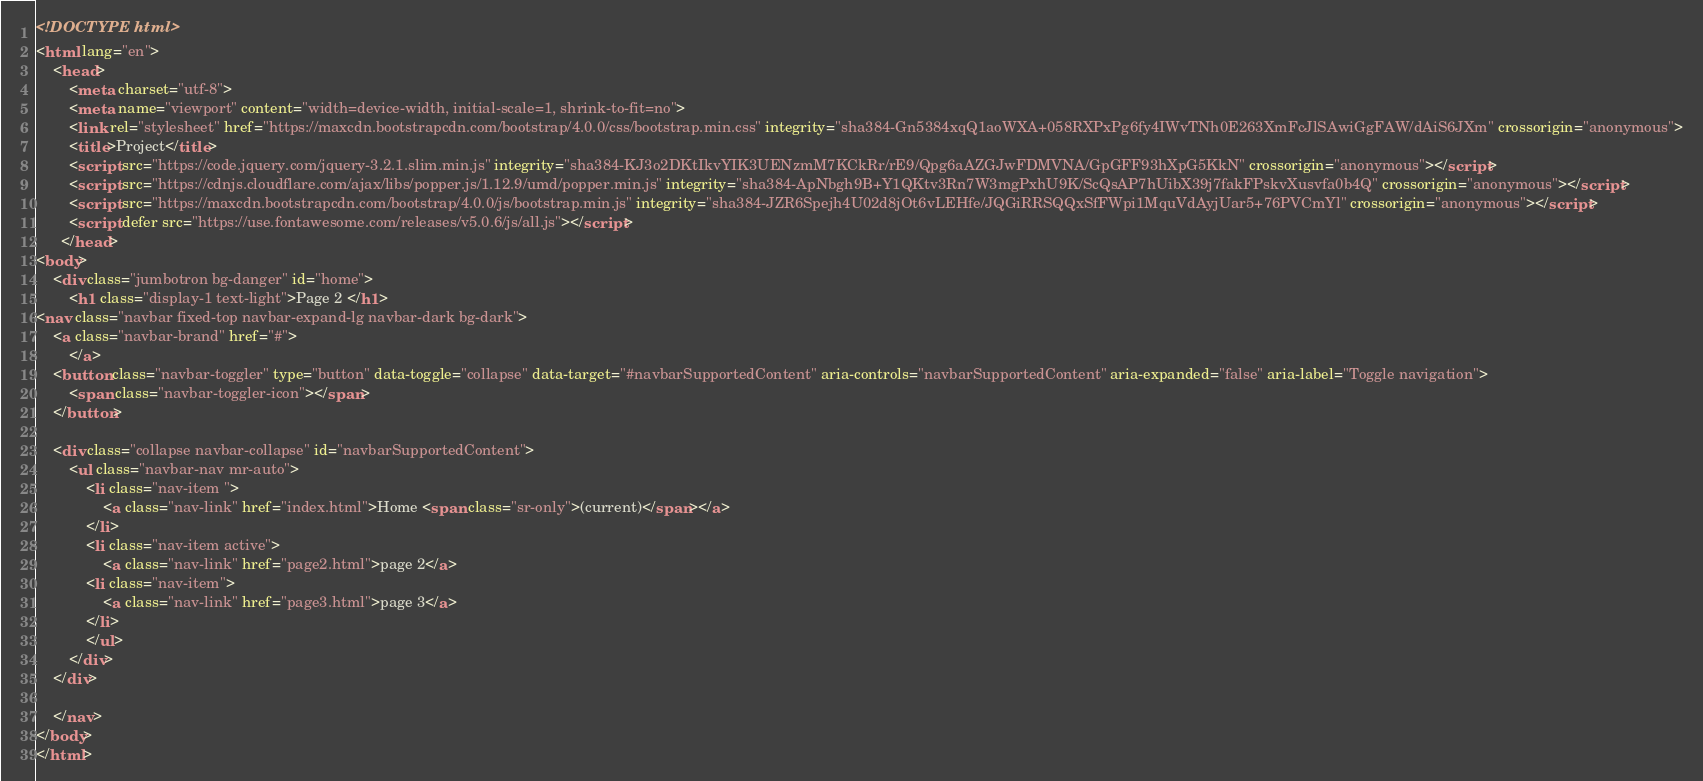Convert code to text. <code><loc_0><loc_0><loc_500><loc_500><_HTML_><!DOCTYPE html>
<html lang="en">
    <head>
        <meta charset="utf-8">
        <meta name="viewport" content="width=device-width, initial-scale=1, shrink-to-fit=no">
        <link rel="stylesheet" href="https://maxcdn.bootstrapcdn.com/bootstrap/4.0.0/css/bootstrap.min.css" integrity="sha384-Gn5384xqQ1aoWXA+058RXPxPg6fy4IWvTNh0E263XmFcJlSAwiGgFAW/dAiS6JXm" crossorigin="anonymous">
        <title>Project</title>
        <script src="https://code.jquery.com/jquery-3.2.1.slim.min.js" integrity="sha384-KJ3o2DKtIkvYIK3UENzmM7KCkRr/rE9/Qpg6aAZGJwFDMVNA/GpGFF93hXpG5KkN" crossorigin="anonymous"></script>
        <script src="https://cdnjs.cloudflare.com/ajax/libs/popper.js/1.12.9/umd/popper.min.js" integrity="sha384-ApNbgh9B+Y1QKtv3Rn7W3mgPxhU9K/ScQsAP7hUibX39j7fakFPskvXusvfa0b4Q" crossorigin="anonymous"></script>
        <script src="https://maxcdn.bootstrapcdn.com/bootstrap/4.0.0/js/bootstrap.min.js" integrity="sha384-JZR6Spejh4U02d8jOt6vLEHfe/JQGiRRSQQxSfFWpi1MquVdAyjUar5+76PVCmYl" crossorigin="anonymous"></script>
        <script defer src="https://use.fontawesome.com/releases/v5.0.6/js/all.js"></script>
      </head>
<body>
    <div class="jumbotron bg-danger" id="home"> 
        <h1 class="display-1 text-light">Page 2 </h1>
<nav class="navbar fixed-top navbar-expand-lg navbar-dark bg-dark">   
    <a class="navbar-brand" href="#">
        </a>
    <button class="navbar-toggler" type="button" data-toggle="collapse" data-target="#navbarSupportedContent" aria-controls="navbarSupportedContent" aria-expanded="false" aria-label="Toggle navigation">
        <span class="navbar-toggler-icon"></span>
    </button>
              
    <div class="collapse navbar-collapse" id="navbarSupportedContent">
        <ul class="navbar-nav mr-auto">
            <li class="nav-item ">
                <a class="nav-link" href="index.html">Home <span class="sr-only">(current)</span></a>
            </li>
            <li class="nav-item active">
                <a class="nav-link" href="page2.html">page 2</a>
            <li class="nav-item">
                <a class="nav-link" href="page3.html">page 3</a>
            </li>
            </ul>
        </div>
    </div>

    </nav>
</body>
</html></code> 